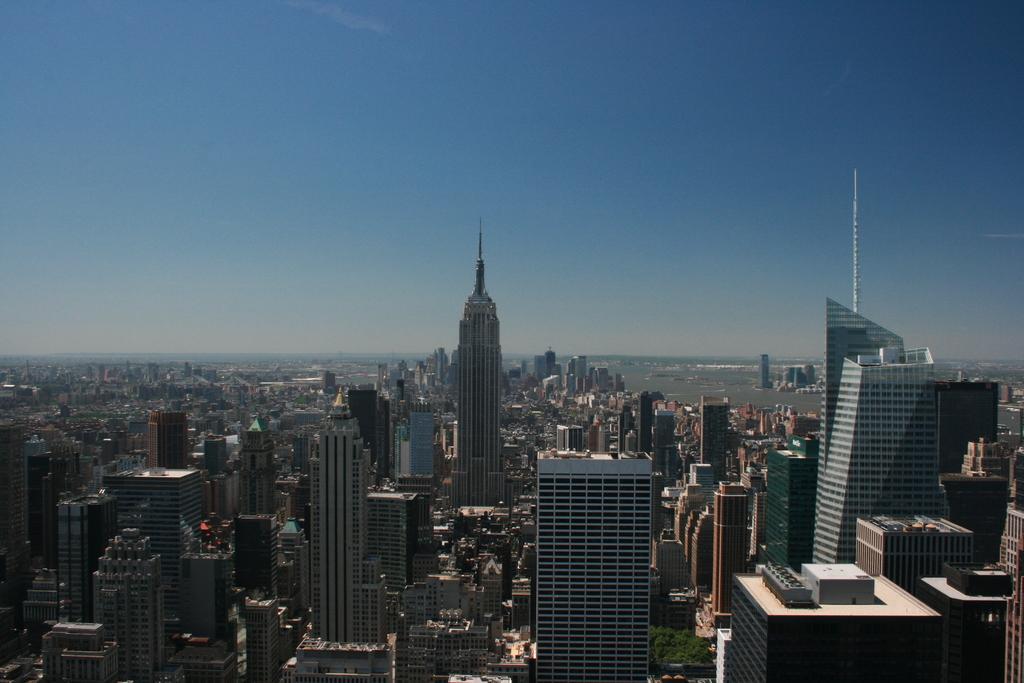Can you describe this image briefly? In this image at the bottom there are some buildings and skyscrapers and some trees, at the top of the image there is sky. 